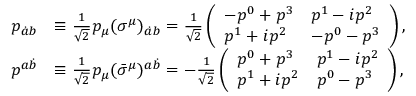<formula> <loc_0><loc_0><loc_500><loc_500>\begin{array} { r l } { p _ { \dot { a } b } } & { \equiv \frac { 1 } { \sqrt { 2 } } p _ { \mu } ( \sigma ^ { \mu } ) _ { \dot { a } b } = \frac { 1 } { \sqrt { 2 } } \left ( \begin{array} { l l } { - p ^ { 0 } + p ^ { 3 } } & { p ^ { 1 } - i p ^ { 2 } } \\ { p ^ { 1 } + i p ^ { 2 } } & { - p ^ { 0 } - p ^ { 3 } } \end{array} \right ) , } \\ { p ^ { a \dot { b } } } & { \equiv \frac { 1 } { \sqrt { 2 } } p _ { \mu } ( \bar { \sigma } ^ { \mu } ) ^ { a \dot { b } } = - \frac { 1 } { \sqrt { 2 } } \left ( \begin{array} { l l } { p ^ { 0 } + p ^ { 3 } } & { p ^ { 1 } - i p ^ { 2 } } \\ { p ^ { 1 } + i p ^ { 2 } } & { p ^ { 0 } - p ^ { 3 } } \end{array} \right ) , } \end{array}</formula> 